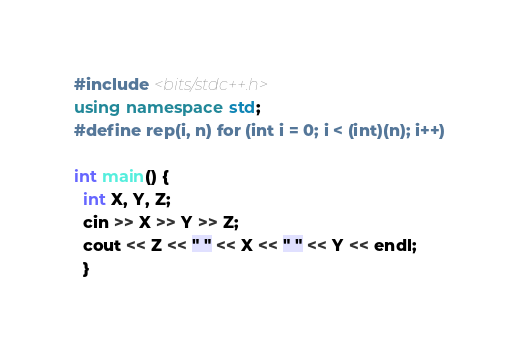<code> <loc_0><loc_0><loc_500><loc_500><_C++_>#include <bits/stdc++.h>
using namespace std;
#define rep(i, n) for (int i = 0; i < (int)(n); i++)

int main() {
  int X, Y, Z;
  cin >> X >> Y >> Z;
  cout << Z << " " << X << " " << Y << endl;
  }
</code> 